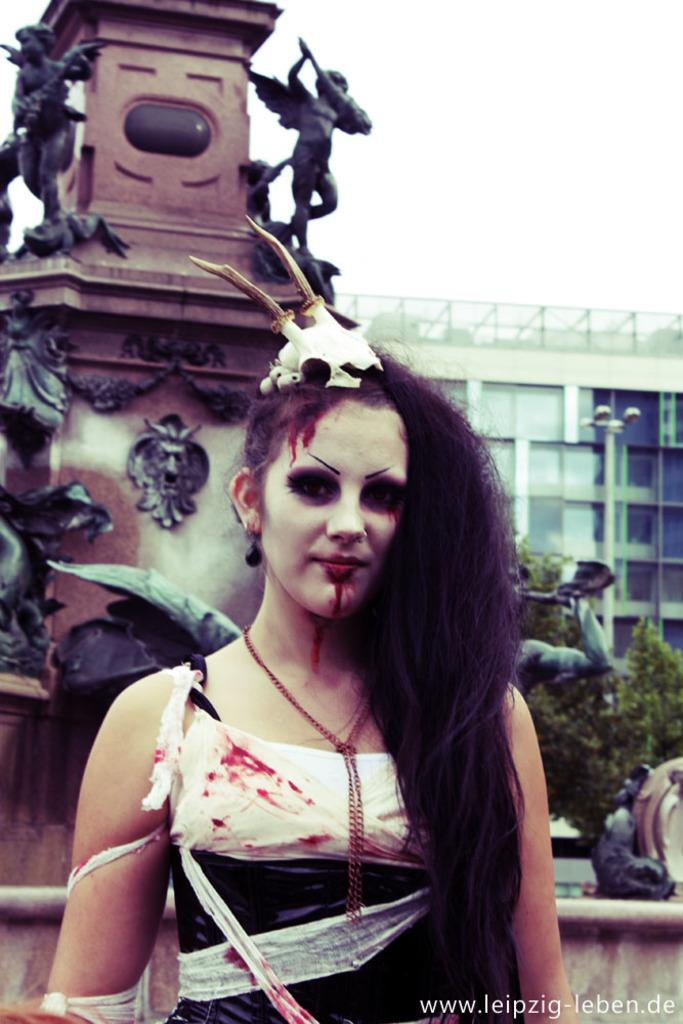Who is present in the image? There is a woman in the image. What can be seen in the background of the image? There are statues, leaves, a pole, a building, and the sky visible in the background of the image. What is written at the bottom of the image? There is something written at the bottom of the image. What type of cork can be seen in the image? There is no cork present in the image. How does the level of the building in the image affect the woman's mood? The level of the building in the image does not affect the woman's mood, as there is no indication of her mood in the image. 